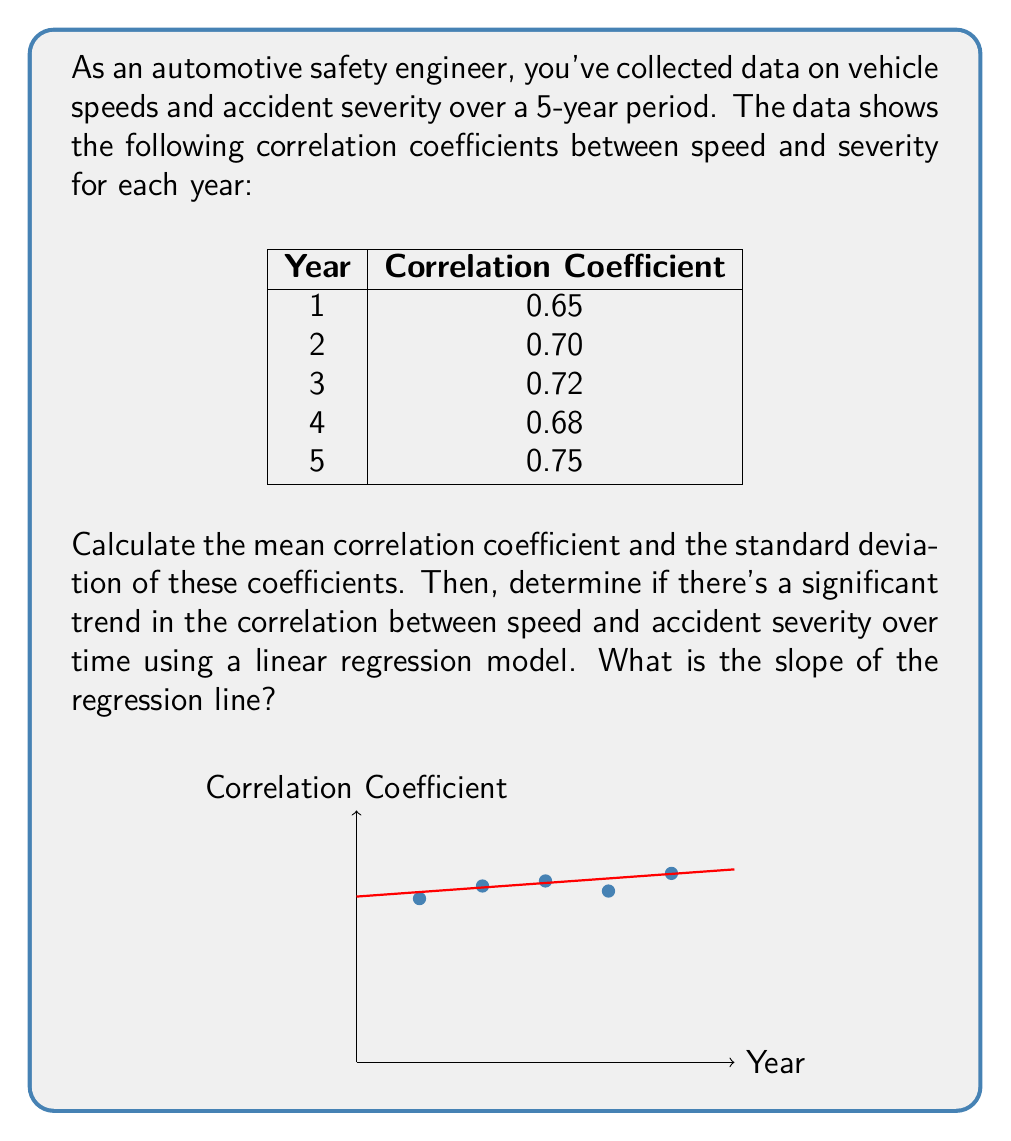Provide a solution to this math problem. 1. Calculate the mean correlation coefficient:
   $$\bar{r} = \frac{0.65 + 0.70 + 0.72 + 0.68 + 0.75}{5} = 0.70$$

2. Calculate the standard deviation:
   $$s = \sqrt{\frac{\sum_{i=1}^{5} (r_i - \bar{r})^2}{n-1}}$$
   $$s = \sqrt{\frac{(0.65-0.70)^2 + (0.70-0.70)^2 + (0.72-0.70)^2 + (0.68-0.70)^2 + (0.75-0.70)^2}{4}}$$
   $$s = \sqrt{\frac{0.0025 + 0 + 0.0004 + 0.0004 + 0.0025}{4}} = \sqrt{0.00145} \approx 0.0381$$

3. For the linear regression, we use the formula:
   $$b = \frac{n\sum xy - \sum x \sum y}{n\sum x^2 - (\sum x)^2}$$
   Where $x$ is the year (1-5) and $y$ is the correlation coefficient.

4. Calculate the necessary sums:
   $$\sum x = 15, \sum y = 3.50, \sum xy = 10.59, \sum x^2 = 55$$

5. Apply the formula:
   $$b = \frac{5(10.59) - (15)(3.50)}{5(55) - (15)^2} = \frac{52.95 - 52.50}{275 - 225} = \frac{0.45}{50} = 0.009$$

6. The slope of the regression line is 0.009, indicating a slight positive trend in the correlation between speed and accident severity over time.
Answer: Mean: 0.70, Standard Deviation: 0.0381, Slope: 0.009 